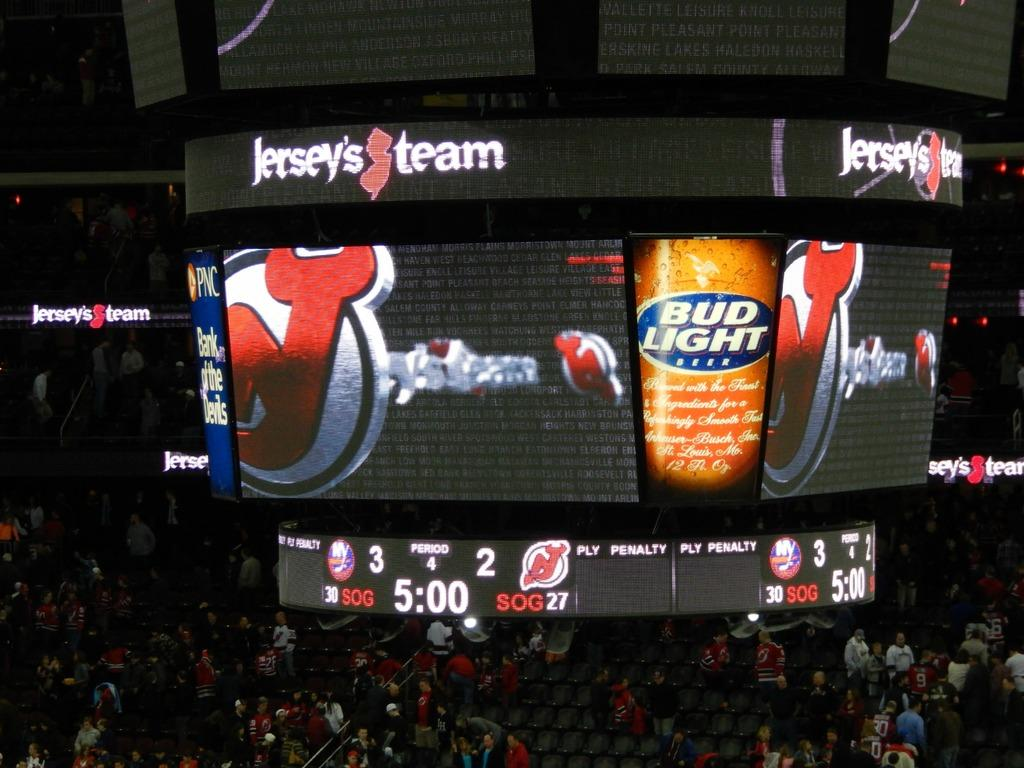<image>
Summarize the visual content of the image. A television display in a stadium advertising Bud Light beer. 